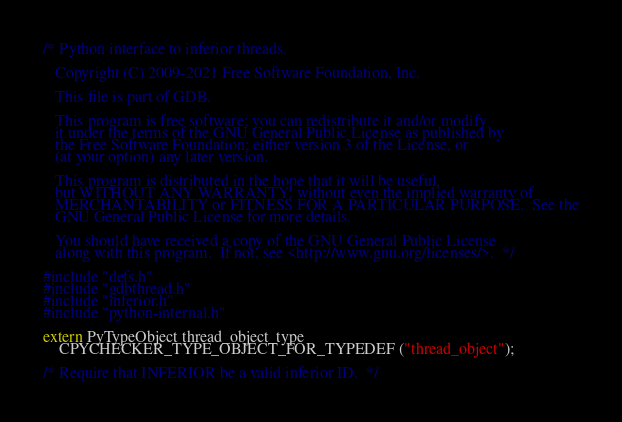<code> <loc_0><loc_0><loc_500><loc_500><_C_>/* Python interface to inferior threads.

   Copyright (C) 2009-2021 Free Software Foundation, Inc.

   This file is part of GDB.

   This program is free software; you can redistribute it and/or modify
   it under the terms of the GNU General Public License as published by
   the Free Software Foundation; either version 3 of the License, or
   (at your option) any later version.

   This program is distributed in the hope that it will be useful,
   but WITHOUT ANY WARRANTY; without even the implied warranty of
   MERCHANTABILITY or FITNESS FOR A PARTICULAR PURPOSE.  See the
   GNU General Public License for more details.

   You should have received a copy of the GNU General Public License
   along with this program.  If not, see <http://www.gnu.org/licenses/>.  */

#include "defs.h"
#include "gdbthread.h"
#include "inferior.h"
#include "python-internal.h"

extern PyTypeObject thread_object_type
    CPYCHECKER_TYPE_OBJECT_FOR_TYPEDEF ("thread_object");

/* Require that INFERIOR be a valid inferior ID.  */</code> 